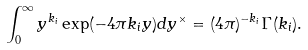<formula> <loc_0><loc_0><loc_500><loc_500>\int _ { 0 } ^ { \infty } y ^ { k _ { i } } \exp ( - 4 \pi k _ { i } y ) d y ^ { \times } = ( 4 \pi ) ^ { - k _ { i } } \Gamma ( k _ { i } ) .</formula> 